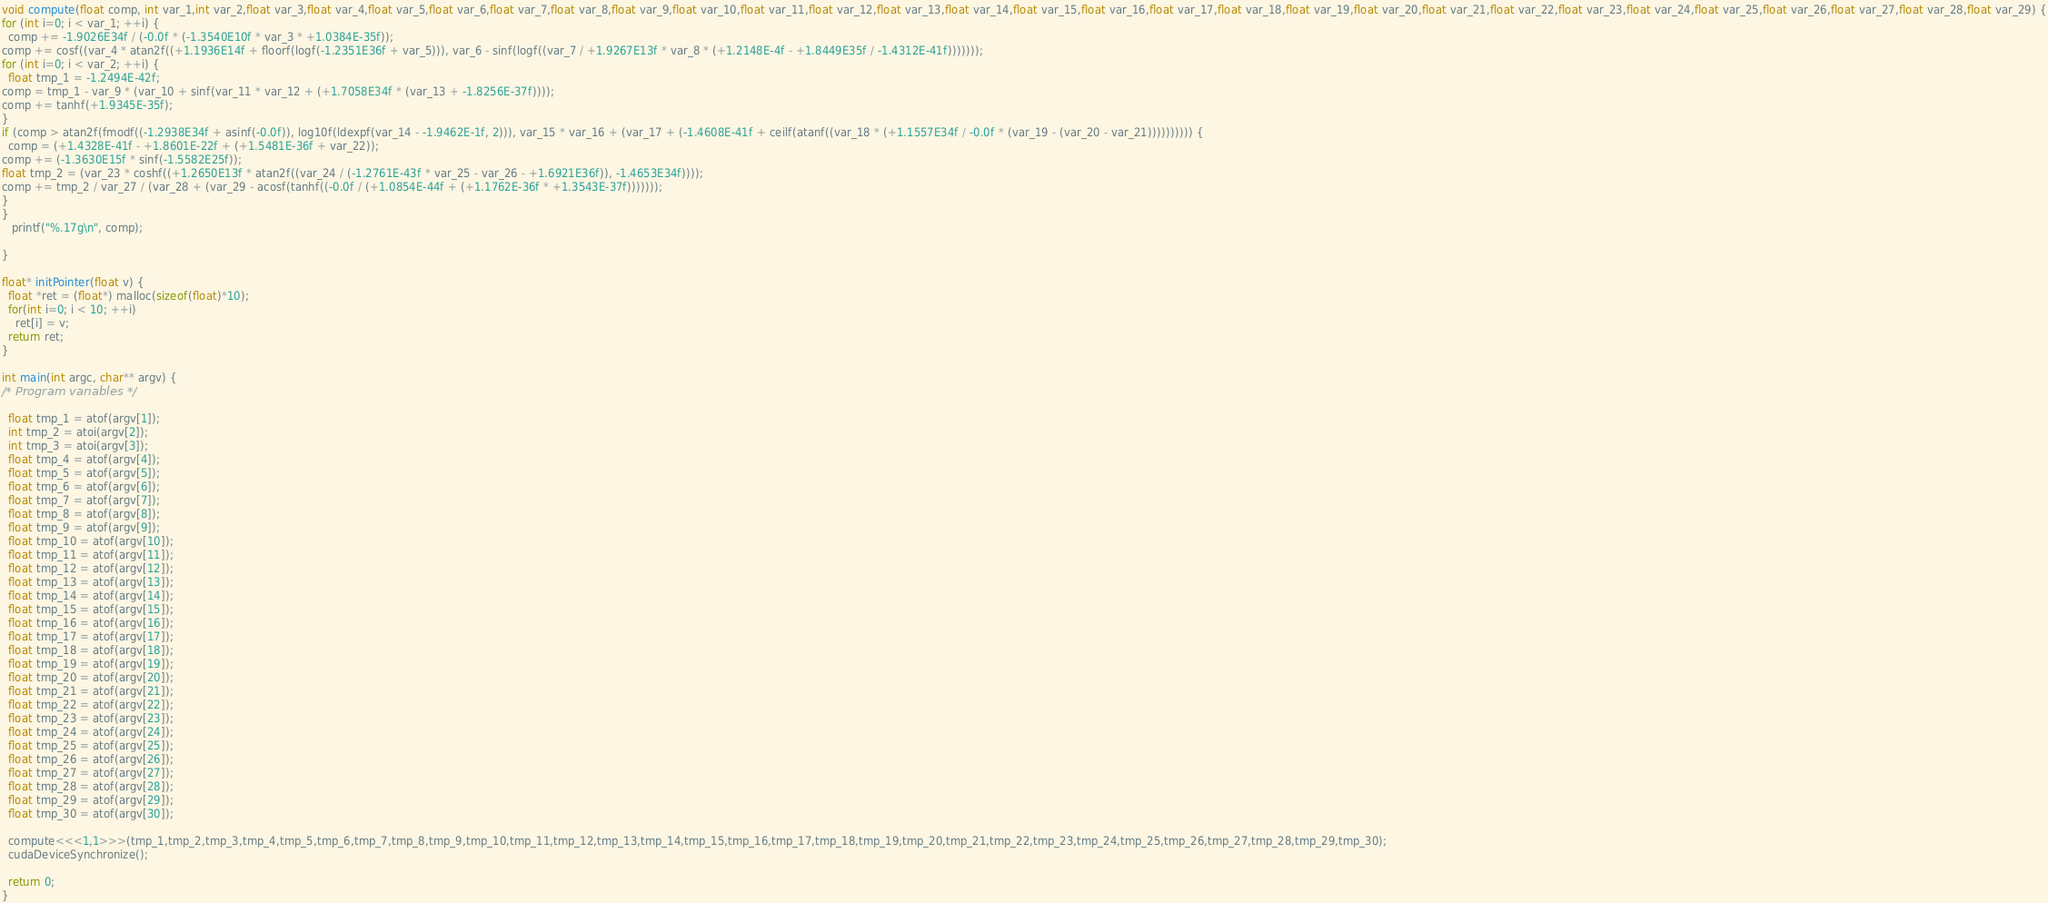<code> <loc_0><loc_0><loc_500><loc_500><_Cuda_>void compute(float comp, int var_1,int var_2,float var_3,float var_4,float var_5,float var_6,float var_7,float var_8,float var_9,float var_10,float var_11,float var_12,float var_13,float var_14,float var_15,float var_16,float var_17,float var_18,float var_19,float var_20,float var_21,float var_22,float var_23,float var_24,float var_25,float var_26,float var_27,float var_28,float var_29) {
for (int i=0; i < var_1; ++i) {
  comp += -1.9026E34f / (-0.0f * (-1.3540E10f * var_3 * +1.0384E-35f));
comp += cosf((var_4 * atan2f((+1.1936E14f + floorf(logf(-1.2351E36f + var_5))), var_6 - sinf(logf((var_7 / +1.9267E13f * var_8 * (+1.2148E-4f - +1.8449E35f / -1.4312E-41f)))))));
for (int i=0; i < var_2; ++i) {
  float tmp_1 = -1.2494E-42f;
comp = tmp_1 - var_9 * (var_10 + sinf(var_11 * var_12 + (+1.7058E34f * (var_13 + -1.8256E-37f))));
comp += tanhf(+1.9345E-35f);
}
if (comp > atan2f(fmodf((-1.2938E34f + asinf(-0.0f)), log10f(ldexpf(var_14 - -1.9462E-1f, 2))), var_15 * var_16 + (var_17 + (-1.4608E-41f + ceilf(atanf((var_18 * (+1.1557E34f / -0.0f * (var_19 - (var_20 - var_21)))))))))) {
  comp = (+1.4328E-41f - +1.8601E-22f + (+1.5481E-36f + var_22));
comp += (-1.3630E15f * sinf(-1.5582E25f));
float tmp_2 = (var_23 * coshf((+1.2650E13f * atan2f((var_24 / (-1.2761E-43f * var_25 - var_26 - +1.6921E36f)), -1.4653E34f))));
comp += tmp_2 / var_27 / (var_28 + (var_29 - acosf(tanhf((-0.0f / (+1.0854E-44f + (+1.1762E-36f * +1.3543E-37f)))))));
}
}
   printf("%.17g\n", comp);

}

float* initPointer(float v) {
  float *ret = (float*) malloc(sizeof(float)*10);
  for(int i=0; i < 10; ++i)
    ret[i] = v;
  return ret;
}

int main(int argc, char** argv) {
/* Program variables */

  float tmp_1 = atof(argv[1]);
  int tmp_2 = atoi(argv[2]);
  int tmp_3 = atoi(argv[3]);
  float tmp_4 = atof(argv[4]);
  float tmp_5 = atof(argv[5]);
  float tmp_6 = atof(argv[6]);
  float tmp_7 = atof(argv[7]);
  float tmp_8 = atof(argv[8]);
  float tmp_9 = atof(argv[9]);
  float tmp_10 = atof(argv[10]);
  float tmp_11 = atof(argv[11]);
  float tmp_12 = atof(argv[12]);
  float tmp_13 = atof(argv[13]);
  float tmp_14 = atof(argv[14]);
  float tmp_15 = atof(argv[15]);
  float tmp_16 = atof(argv[16]);
  float tmp_17 = atof(argv[17]);
  float tmp_18 = atof(argv[18]);
  float tmp_19 = atof(argv[19]);
  float tmp_20 = atof(argv[20]);
  float tmp_21 = atof(argv[21]);
  float tmp_22 = atof(argv[22]);
  float tmp_23 = atof(argv[23]);
  float tmp_24 = atof(argv[24]);
  float tmp_25 = atof(argv[25]);
  float tmp_26 = atof(argv[26]);
  float tmp_27 = atof(argv[27]);
  float tmp_28 = atof(argv[28]);
  float tmp_29 = atof(argv[29]);
  float tmp_30 = atof(argv[30]);

  compute<<<1,1>>>(tmp_1,tmp_2,tmp_3,tmp_4,tmp_5,tmp_6,tmp_7,tmp_8,tmp_9,tmp_10,tmp_11,tmp_12,tmp_13,tmp_14,tmp_15,tmp_16,tmp_17,tmp_18,tmp_19,tmp_20,tmp_21,tmp_22,tmp_23,tmp_24,tmp_25,tmp_26,tmp_27,tmp_28,tmp_29,tmp_30);
  cudaDeviceSynchronize();

  return 0;
}
</code> 